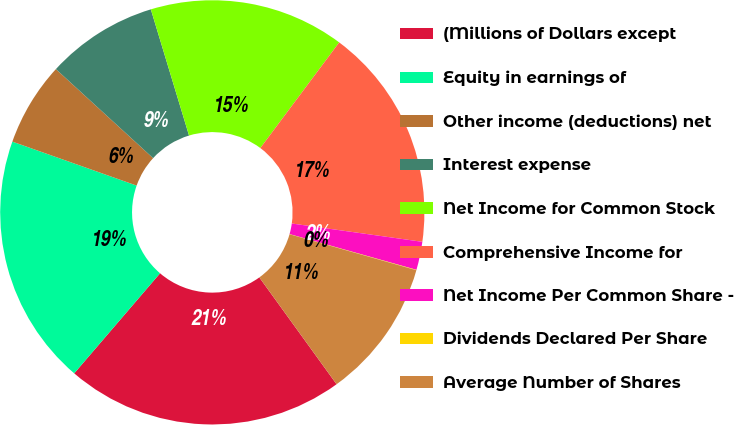Convert chart to OTSL. <chart><loc_0><loc_0><loc_500><loc_500><pie_chart><fcel>(Millions of Dollars except<fcel>Equity in earnings of<fcel>Other income (deductions) net<fcel>Interest expense<fcel>Net Income for Common Stock<fcel>Comprehensive Income for<fcel>Net Income Per Common Share -<fcel>Dividends Declared Per Share<fcel>Average Number of Shares<nl><fcel>21.25%<fcel>19.13%<fcel>6.39%<fcel>8.52%<fcel>14.89%<fcel>17.01%<fcel>2.15%<fcel>0.03%<fcel>10.64%<nl></chart> 